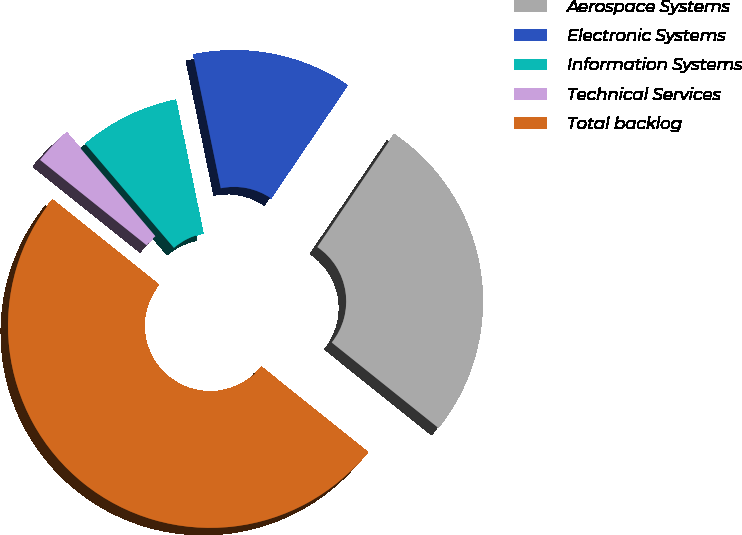Convert chart to OTSL. <chart><loc_0><loc_0><loc_500><loc_500><pie_chart><fcel>Aerospace Systems<fcel>Electronic Systems<fcel>Information Systems<fcel>Technical Services<fcel>Total backlog<nl><fcel>26.26%<fcel>12.72%<fcel>8.0%<fcel>3.02%<fcel>50.0%<nl></chart> 